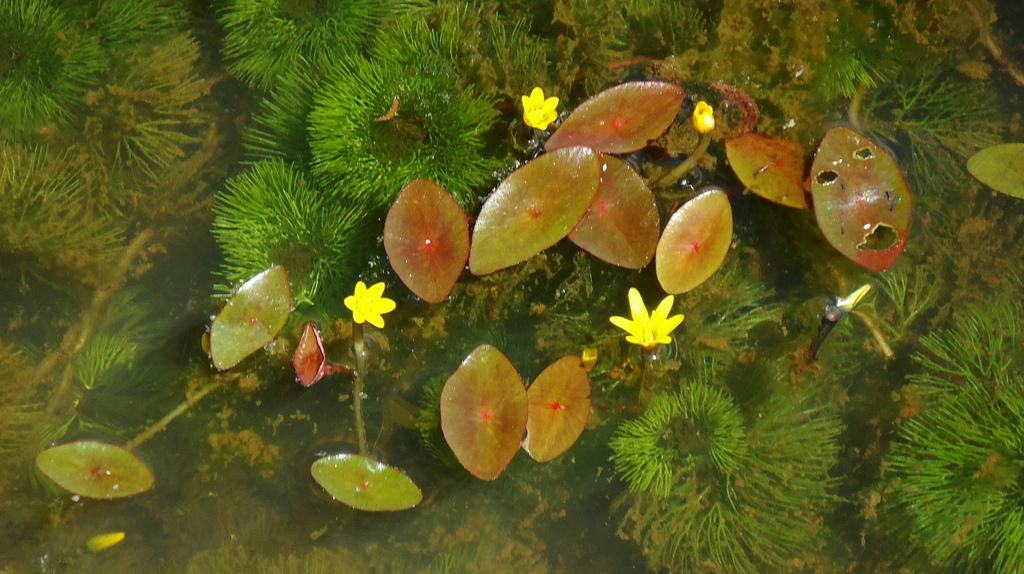What type of living organisms can be seen in the image? Flowers and plants are visible in the image. What is the primary element in which the flowers and plants are situated? There is water visible in the image. How many babies are visible in the image? There are no babies present in the image; it features flowers and plants in water. What type of sign can be seen in the image? There is no sign present in the image. 